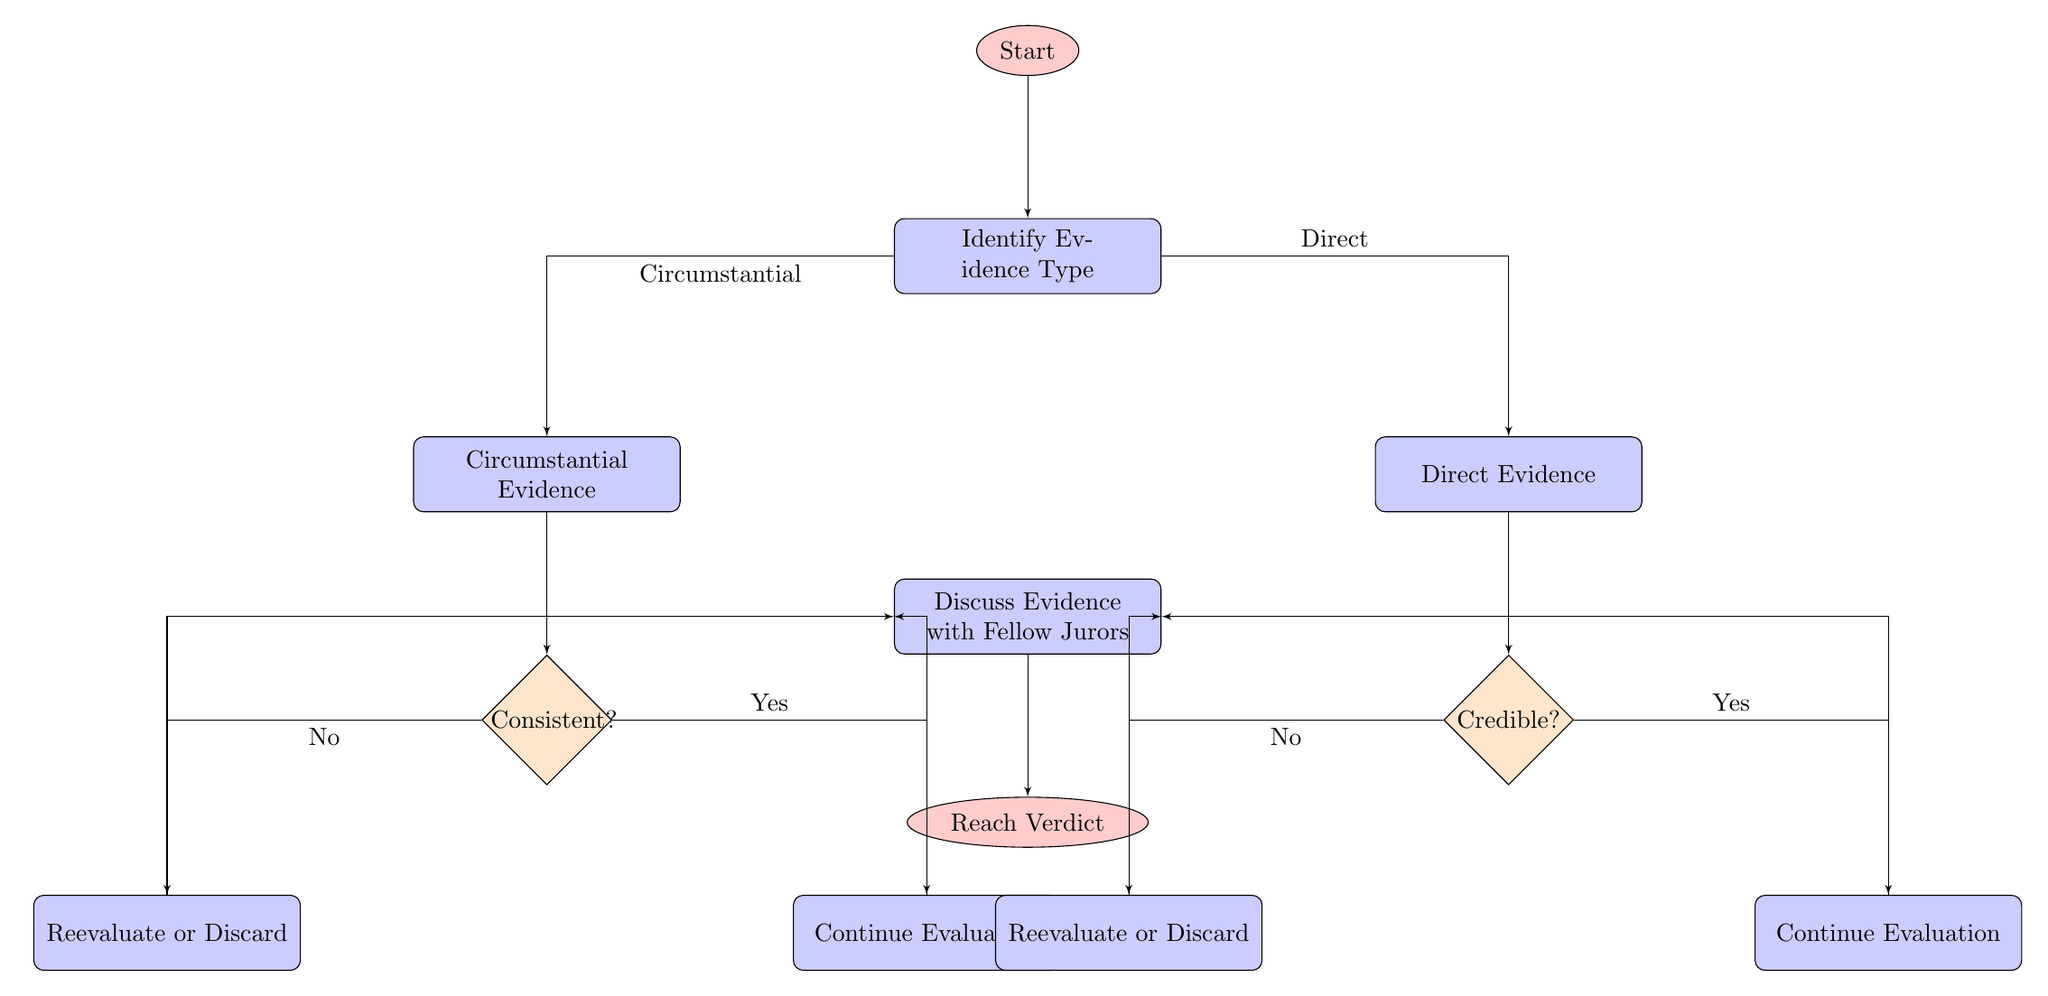What is the first step in the diagram? The first step is labeled "Start," which is the entry point of the flowchart. According to the diagram, it initiates the process of weighing evidence.
Answer: Start How many types of evidence are identified in the diagram? The diagram identifies two types of evidence: circumstantial and direct. These are specified in the "Identify Evidence Type" node.
Answer: Two What action follows the consistency check if the evidence is consistent? If the evidence is consistent, the action specified is to "Continue Evaluation." This indicates that the evaluation of evidence proceeds positively after this check.
Answer: Continue Evaluation What does the diagram indicate happens if direct evidence is found not credible? If direct evidence is found not credible, the corresponding action is to "Reevaluate or Discard." This suggests that unreliable sources of evidence are reconsidered or dismissed in this evaluation process.
Answer: Reevaluate or Discard Which node leads to deliberation after evaluating circumstantial evidence? The "Continue Evaluation" node leads to deliberation after evaluating circumstantial evidence, indicating that the process continues to discuss evidence regardless of consistency.
Answer: Continue Evaluation What is the final action described in the flowchart? The final action in the flowchart is to "Reach Verdict," which means the combined evaluations from the previous assessments are used to come to a conclusion about the case.
Answer: Reach Verdict What happens if circumstantial evidence is inconsistent with direct evidence? If circumstantial evidence is inconsistent with direct evidence, the diagram indicates that the next step is to "Reevaluate or Discard," suggesting a reassessment of the evidence's relevance or validity.
Answer: Reevaluate or Discard How does the diagram view the relationship between credible evidence and deliberation? The diagram suggests that if the evidence is credible, it leads directly to deliberation, indicating that credible direct evidence is significant enough to discuss further with fellow jurors.
Answer: Discuss Evidence with Fellow Jurors What type of evidence requires a credibility check in the flowchart? Direct evidence requires a credibility check. This is clearly indicated in the "Direct Evidence" node leading to the "Credibility Check" decision point in the flowchart.
Answer: Direct Evidence 